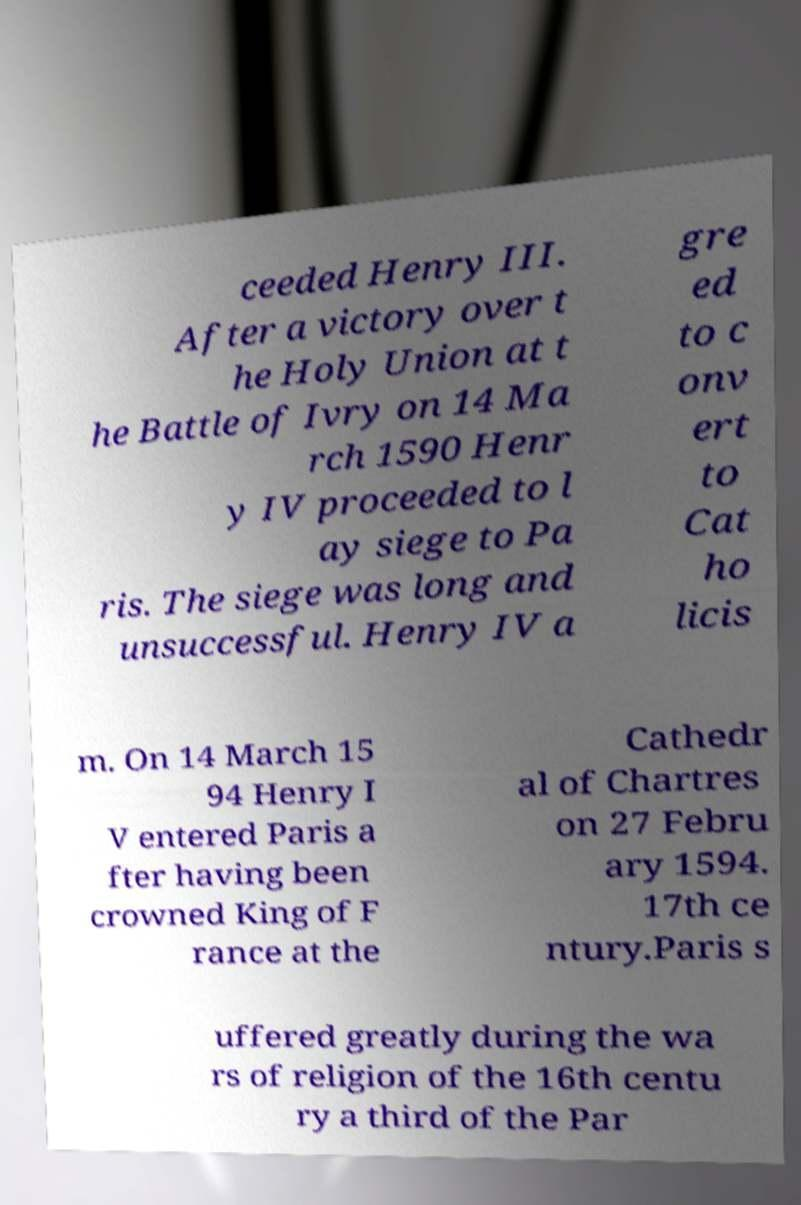Please identify and transcribe the text found in this image. ceeded Henry III. After a victory over t he Holy Union at t he Battle of Ivry on 14 Ma rch 1590 Henr y IV proceeded to l ay siege to Pa ris. The siege was long and unsuccessful. Henry IV a gre ed to c onv ert to Cat ho licis m. On 14 March 15 94 Henry I V entered Paris a fter having been crowned King of F rance at the Cathedr al of Chartres on 27 Febru ary 1594. 17th ce ntury.Paris s uffered greatly during the wa rs of religion of the 16th centu ry a third of the Par 